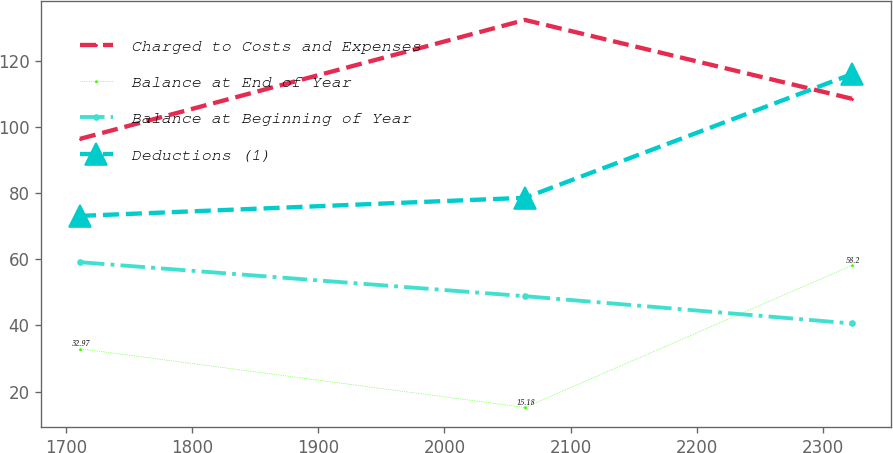Convert chart to OTSL. <chart><loc_0><loc_0><loc_500><loc_500><line_chart><ecel><fcel>Charged to Costs and Expenses<fcel>Balance at End of Year<fcel>Balance at Beginning of Year<fcel>Deductions (1)<nl><fcel>1711.22<fcel>96.49<fcel>32.97<fcel>59.16<fcel>73.17<nl><fcel>2063.88<fcel>132.49<fcel>15.18<fcel>48.87<fcel>78.66<nl><fcel>2323.04<fcel>108.63<fcel>58.2<fcel>40.61<fcel>116.11<nl></chart> 